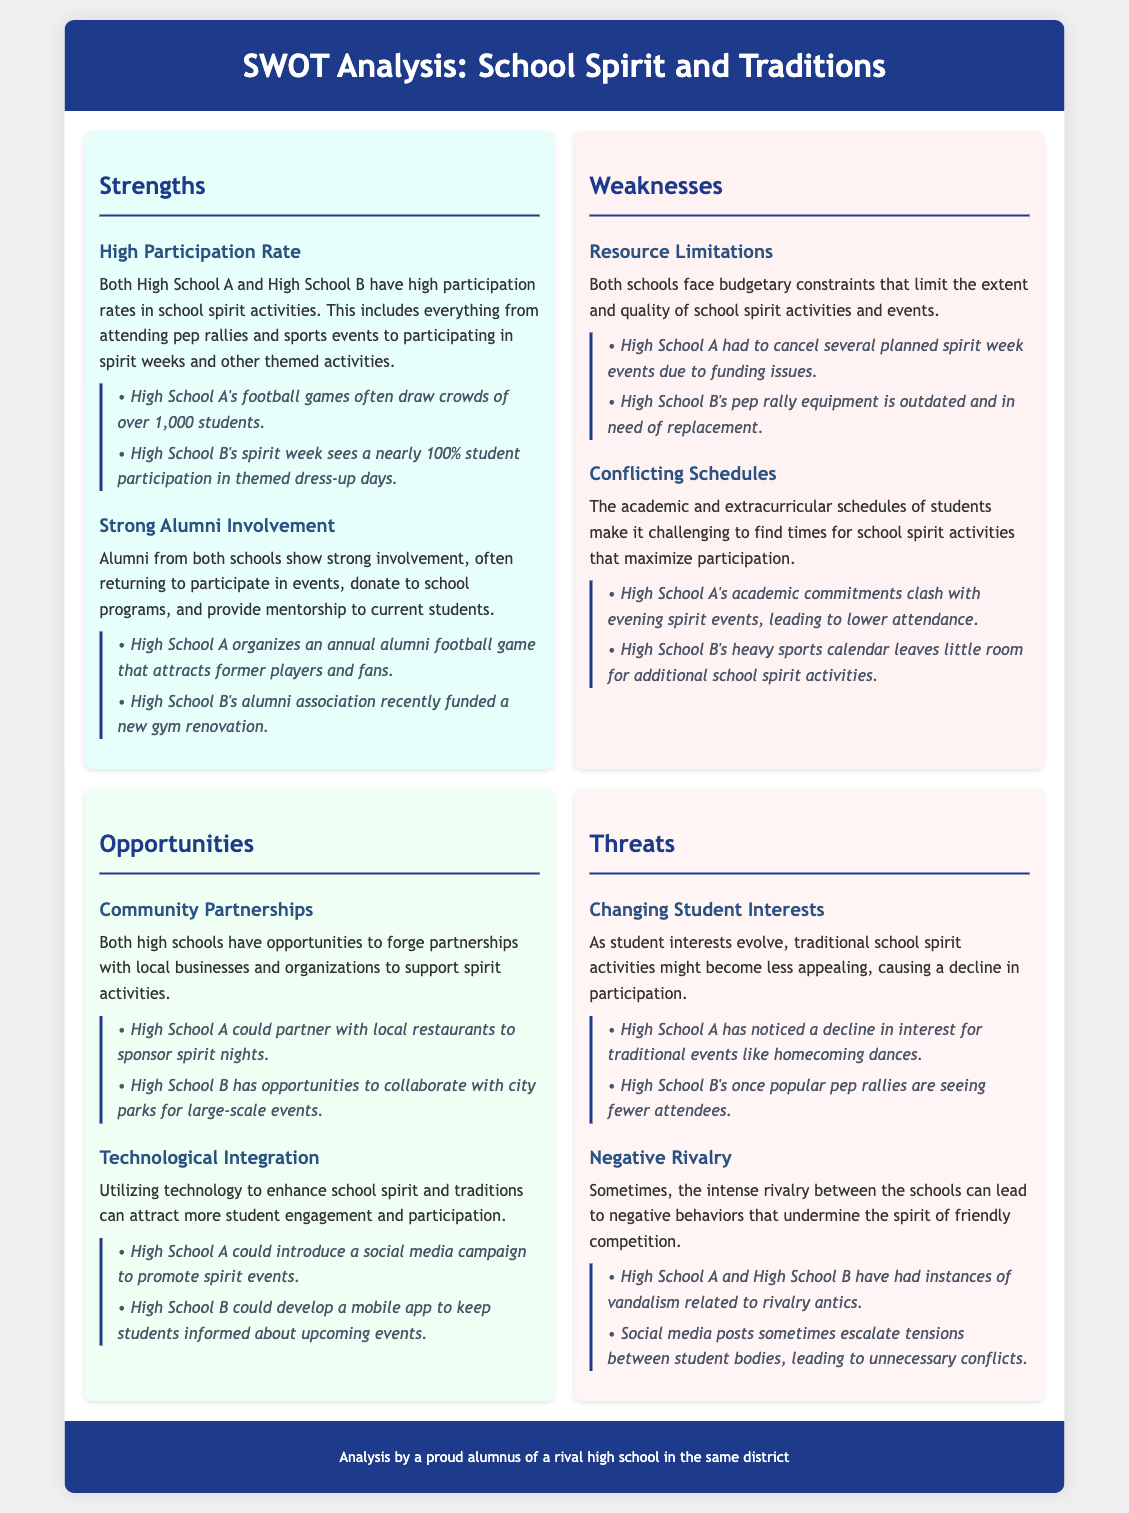what is the participation rate for High School A football games? The document states that High School A's football games often draw crowds of over 1,000 students.
Answer: over 1,000 students what is a common problem faced by both schools regarding spirit activities? Both schools face budgetary constraints that limit the extent and quality of school spirit activities and events.
Answer: budgetary constraints what is a strength related to alumni for both schools? Alumni from both schools show strong involvement, often returning to participate in events, donate to school programs, and provide mentorship to current students.
Answer: strong involvement how do conflicting schedules affect school spirit activities? The academic and extracurricular schedules of students make it challenging to find times for school spirit activities that maximize participation.
Answer: challenging to find times what is one opportunity for High School A regarding community partnerships? High School A could partner with local restaurants to sponsor spirit nights.
Answer: partner with local restaurants which section of the SWOT analysis discusses changing interests? The strengths section does not discuss this; it is mentioned under the threats section regarding evolving student interests.
Answer: threats what is one negative behavior resulting from the rivalry? High School A and High School B have had instances of vandalism related to rivalry antics.
Answer: vandalism what recent support did High School B's alumni association provide? The alumni association recently funded a new gym renovation.
Answer: funded a new gym renovation 